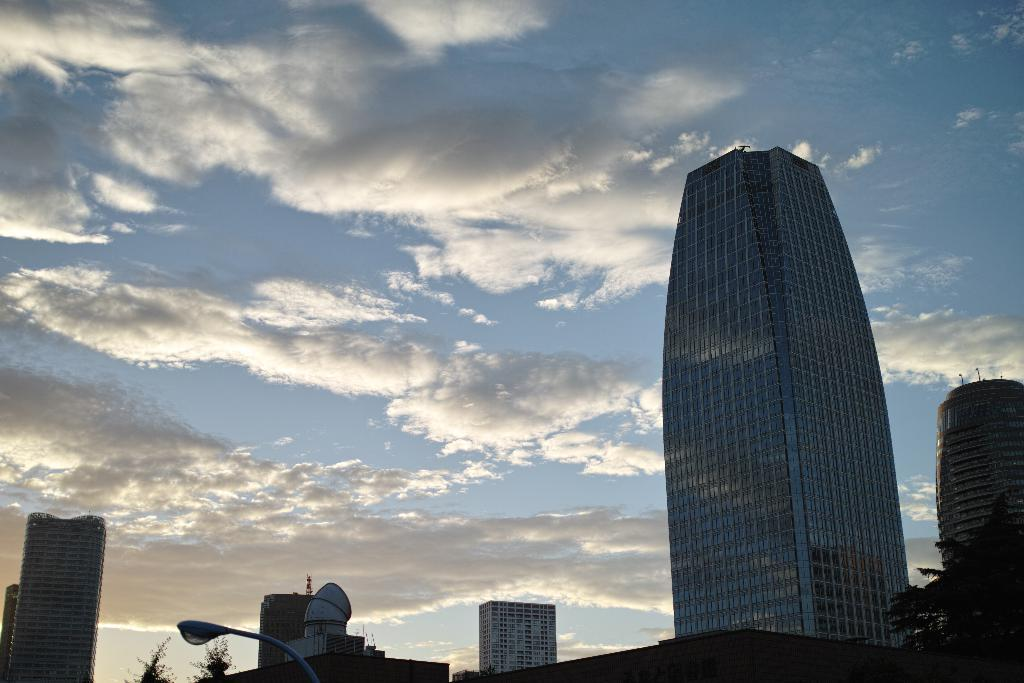What type of structures can be seen in the image? There are buildings in the image. What other natural elements are present in the image? There are trees in the image. Can you describe the lighting conditions in the image? There is light visible in the image. What can be seen in the background of the image? The sky is visible in the background of the image. What is the weather like in the image? The presence of clouds in the sky suggests that it might be partly cloudy. How much profit did the creature make in the image? There is no creature present in the image, and therefore no profit can be associated with it. 